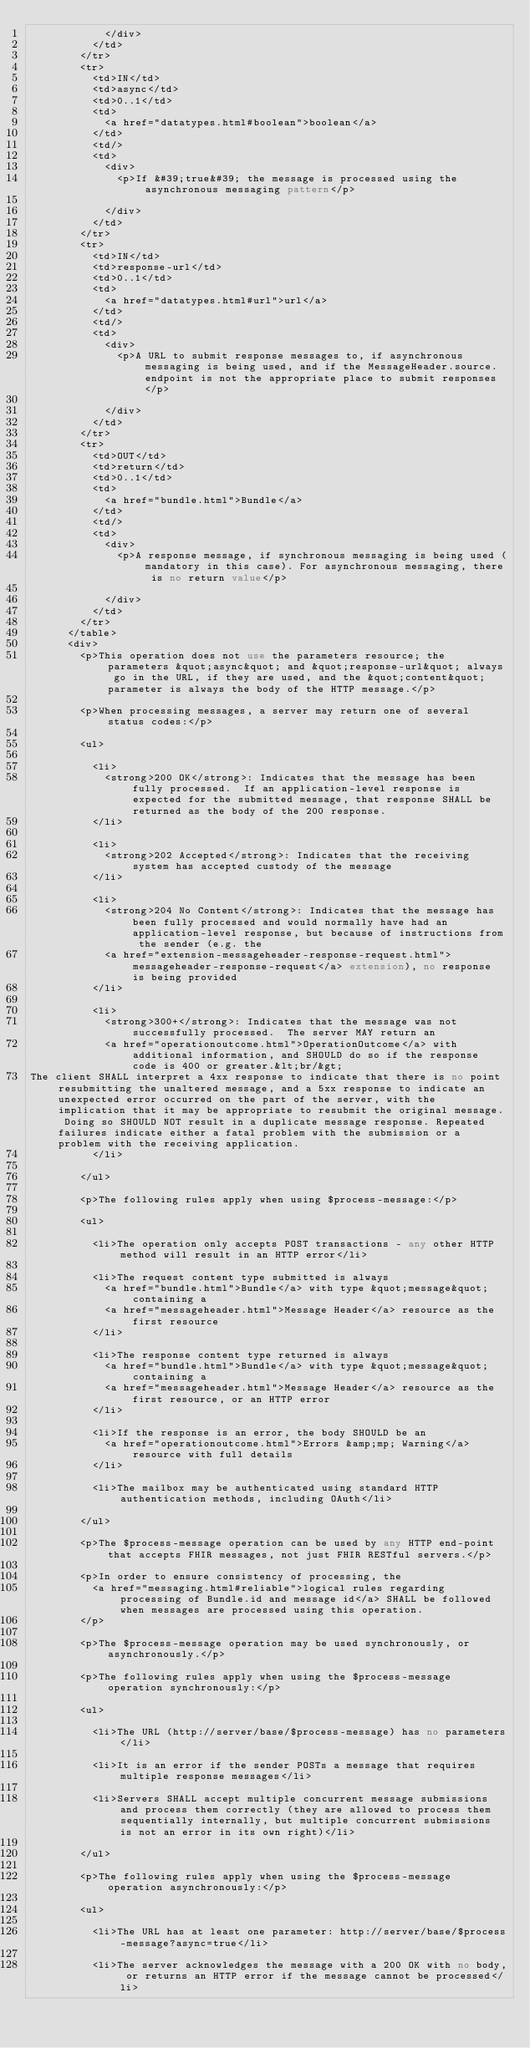<code> <loc_0><loc_0><loc_500><loc_500><_XML_>            </div>
          </td>
        </tr>
        <tr>
          <td>IN</td>
          <td>async</td>
          <td>0..1</td>
          <td>
            <a href="datatypes.html#boolean">boolean</a>
          </td>
          <td/>
          <td>
            <div>
              <p>If &#39;true&#39; the message is processed using the asynchronous messaging pattern</p>

            </div>
          </td>
        </tr>
        <tr>
          <td>IN</td>
          <td>response-url</td>
          <td>0..1</td>
          <td>
            <a href="datatypes.html#url">url</a>
          </td>
          <td/>
          <td>
            <div>
              <p>A URL to submit response messages to, if asynchronous messaging is being used, and if the MessageHeader.source.endpoint is not the appropriate place to submit responses</p>

            </div>
          </td>
        </tr>
        <tr>
          <td>OUT</td>
          <td>return</td>
          <td>0..1</td>
          <td>
            <a href="bundle.html">Bundle</a>
          </td>
          <td/>
          <td>
            <div>
              <p>A response message, if synchronous messaging is being used (mandatory in this case). For asynchronous messaging, there is no return value</p>

            </div>
          </td>
        </tr>
      </table>
      <div>
        <p>This operation does not use the parameters resource; the parameters &quot;async&quot; and &quot;response-url&quot; always go in the URL, if they are used, and the &quot;content&quot; parameter is always the body of the HTTP message.</p>

        <p>When processing messages, a server may return one of several status codes:</p>

        <ul>

          <li>
            <strong>200 OK</strong>: Indicates that the message has been fully processed.  If an application-level response is expected for the submitted message, that response SHALL be returned as the body of the 200 response.
          </li>

          <li>
            <strong>202 Accepted</strong>: Indicates that the receiving system has accepted custody of the message
          </li>

          <li>
            <strong>204 No Content</strong>: Indicates that the message has been fully processed and would normally have had an application-level response, but because of instructions from the sender (e.g. the 
            <a href="extension-messageheader-response-request.html">messageheader-response-request</a> extension), no response is being provided
          </li>

          <li>
            <strong>300+</strong>: Indicates that the message was not successfully processed.  The server MAY return an 
            <a href="operationoutcome.html">OperationOutcome</a> with additional information, and SHOULD do so if the response code is 400 or greater.&lt;br/&gt;
The client SHALL interpret a 4xx response to indicate that there is no point resubmitting the unaltered message, and a 5xx response to indicate an unexpected error occurred on the part of the server, with the implication that it may be appropriate to resubmit the original message. Doing so SHOULD NOT result in a duplicate message response. Repeated failures indicate either a fatal problem with the submission or a problem with the receiving application.
          </li>

        </ul>

        <p>The following rules apply when using $process-message:</p>

        <ul>

          <li>The operation only accepts POST transactions - any other HTTP method will result in an HTTP error</li>

          <li>The request content type submitted is always 
            <a href="bundle.html">Bundle</a> with type &quot;message&quot; containing a 
            <a href="messageheader.html">Message Header</a> resource as the first resource
          </li>

          <li>The response content type returned is always 
            <a href="bundle.html">Bundle</a> with type &quot;message&quot; containing a 
            <a href="messageheader.html">Message Header</a> resource as the first resource, or an HTTP error
          </li>

          <li>If the response is an error, the body SHOULD be an 
            <a href="operationoutcome.html">Errors &amp;mp; Warning</a> resource with full details
          </li>

          <li>The mailbox may be authenticated using standard HTTP authentication methods, including OAuth</li>

        </ul>

        <p>The $process-message operation can be used by any HTTP end-point that accepts FHIR messages, not just FHIR RESTful servers.</p>

        <p>In order to ensure consistency of processing, the 
          <a href="messaging.html#reliable">logical rules regarding processing of Bundle.id and message id</a> SHALL be followed when messages are processed using this operation.
        </p>

        <p>The $process-message operation may be used synchronously, or asynchronously.</p>

        <p>The following rules apply when using the $process-message operation synchronously:</p>

        <ul>

          <li>The URL (http://server/base/$process-message) has no parameters</li>

          <li>It is an error if the sender POSTs a message that requires multiple response messages</li>

          <li>Servers SHALL accept multiple concurrent message submissions and process them correctly (they are allowed to process them sequentially internally, but multiple concurrent submissions is not an error in its own right)</li>

        </ul>

        <p>The following rules apply when using the $process-message operation asynchronously:</p>

        <ul>

          <li>The URL has at least one parameter: http://server/base/$process-message?async=true</li>

          <li>The server acknowledges the message with a 200 OK with no body, or returns an HTTP error if the message cannot be processed</li>
</code> 